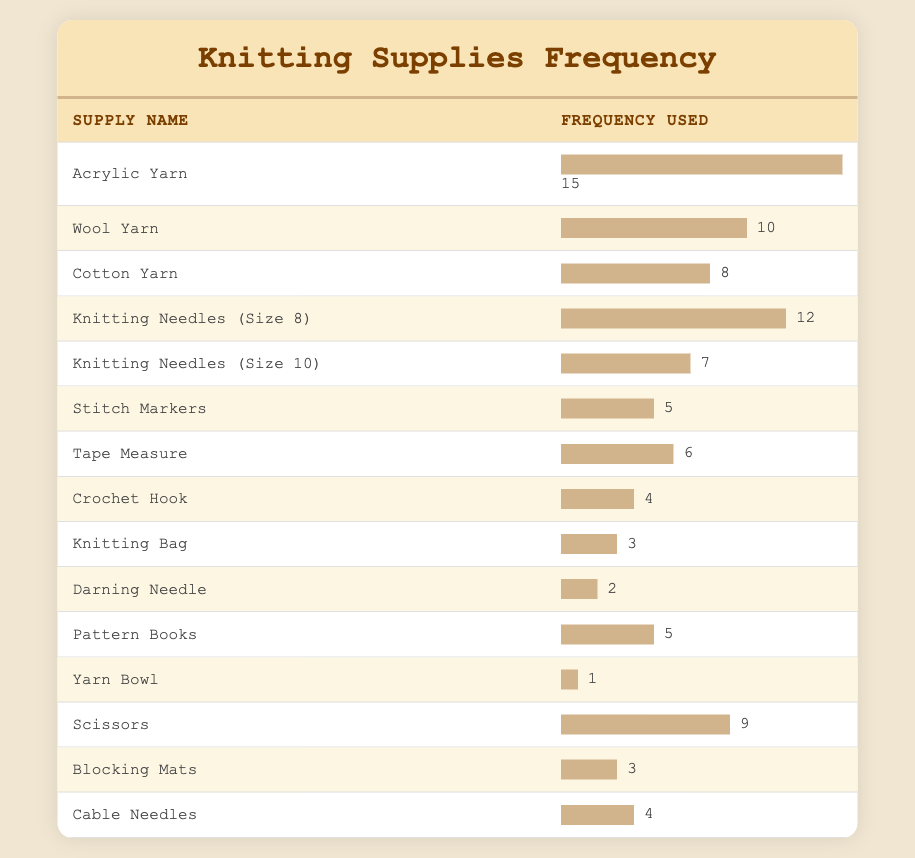What is the most frequently used knitting supply? The table shows that "Acrylic Yarn" has the highest frequency of use at 15, compared to the other supplies listed.
Answer: Acrylic Yarn How many different types of knitting needles are listed in the table? The table lists two different types of knitting needles: "Knitting Needles (Size 8)" and "Knitting Needles (Size 10)".
Answer: 2 What is the total frequency of yarns used (Acrylic, Wool, and Cotton)? To find the total frequency of yarns, we sum the frequency of "Acrylic Yarn" (15), "Wool Yarn" (10), and "Cotton Yarn" (8): 15 + 10 + 8 = 33.
Answer: 33 Is it true that "Scissors" are used more frequently than "Tape Measure"? The frequency for "Scissors" is 9, while the frequency for "Tape Measure" is 6. Since 9 is greater than 6, the statement is true.
Answer: Yes What is the average frequency of all the knitting supplies listed in the table? To find the average, we first sum the frequency values (15 + 10 + 8 + 12 + 7 + 5 + 6 + 4 + 3 + 2 + 5 + 1 + 9 + 3 + 4 = 81). There are 15 supplies, so the average is 81 divided by 15, which is 5.4.
Answer: 5.4 Which supply has the lowest frequency and what is that frequency? The table indicates that "Yarn Bowl" has the lowest frequency at 1.
Answer: Yarn Bowl, 1 What is the difference in frequency between the most used and the least used supplies? The most used supply is "Acrylic Yarn" with a frequency of 15, and the least used is "Yarn Bowl" with a frequency of 1. The difference is 15 - 1 = 14.
Answer: 14 How often are "Stitch Markers" and "Blocking Mats" used together compared to "Wool Yarn"? "Stitch Markers" have a frequency of 5 and "Blocking Mats" have a frequency of 3, together that is 5 + 3 = 8. "Wool Yarn" has a frequency of 10. Since 8 is less than 10, they are used less frequently together than "Wool Yarn".
Answer: They are used less frequently together than Wool Yarn How many more times is "Acrylic Yarn" used compared to "Darning Needle"? The frequency of "Acrylic Yarn" is 15 and "Darning Needle" is 2. The difference is 15 - 2 = 13, indicating "Acrylic Yarn" is used 13 more times.
Answer: 13 